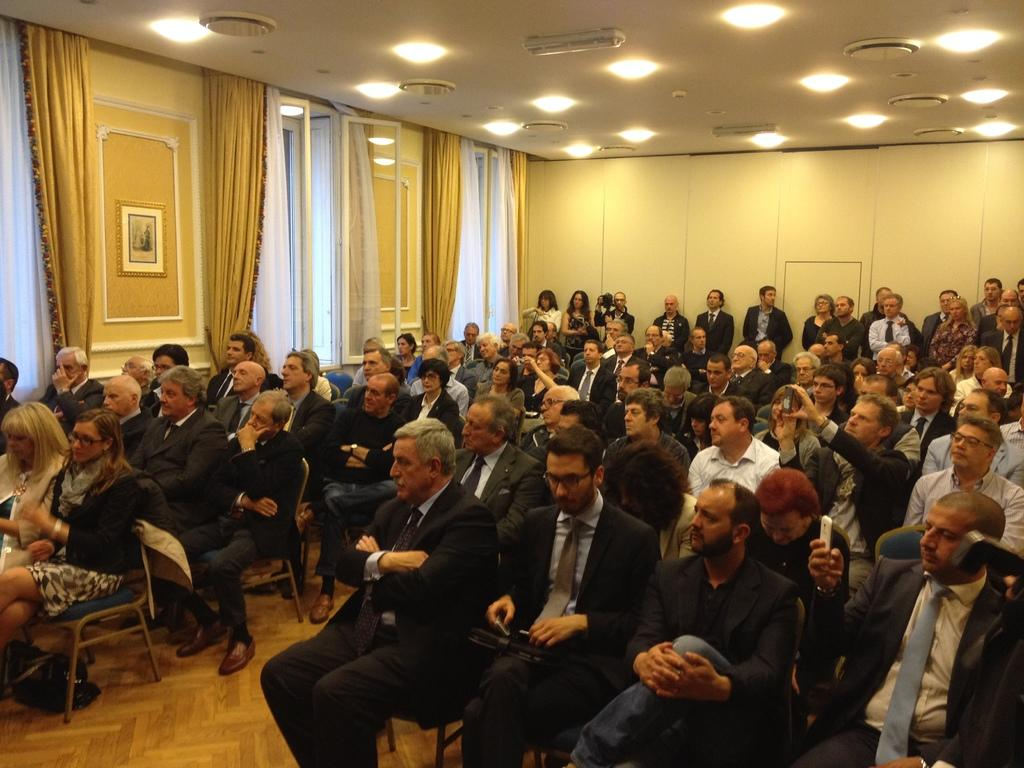How many people are in the image? There is a group of people in the image. What are some of the people doing in the image? Some people are sitting on chairs, while others are standing on the floor. What can be seen in the background of the image? There are windows with curtains, lights, and a wall visible in the background. What type of cabbage is being used as a hat by one of the people in the image? There is no cabbage present in the image, nor is anyone wearing a cabbage as a hat. Can you see any mice running around in the image? There are no mice visible in the image. 